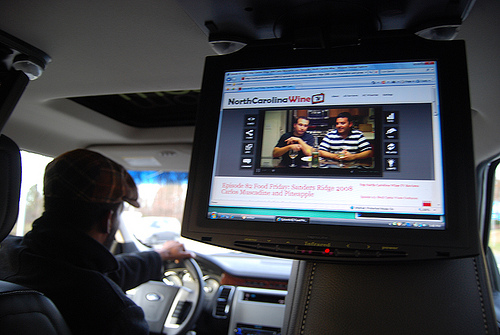<image>
Is there a man behind the video? No. The man is not behind the video. From this viewpoint, the man appears to be positioned elsewhere in the scene. 